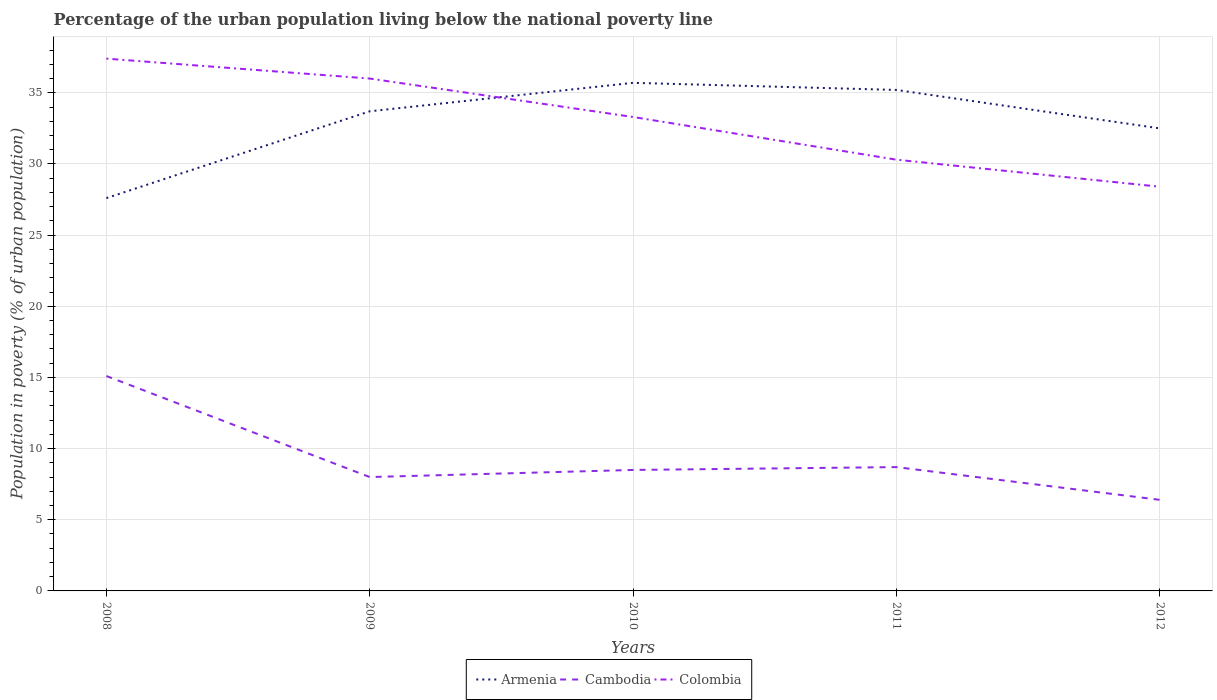How many different coloured lines are there?
Keep it short and to the point. 3. Across all years, what is the maximum percentage of the urban population living below the national poverty line in Cambodia?
Ensure brevity in your answer.  6.4. What is the total percentage of the urban population living below the national poverty line in Cambodia in the graph?
Keep it short and to the point. 6.4. What is the difference between the highest and the lowest percentage of the urban population living below the national poverty line in Armenia?
Offer a terse response. 3. How many lines are there?
Offer a very short reply. 3. What is the difference between two consecutive major ticks on the Y-axis?
Your response must be concise. 5. Are the values on the major ticks of Y-axis written in scientific E-notation?
Ensure brevity in your answer.  No. Does the graph contain any zero values?
Your answer should be very brief. No. How are the legend labels stacked?
Provide a short and direct response. Horizontal. What is the title of the graph?
Keep it short and to the point. Percentage of the urban population living below the national poverty line. Does "Philippines" appear as one of the legend labels in the graph?
Your response must be concise. No. What is the label or title of the X-axis?
Give a very brief answer. Years. What is the label or title of the Y-axis?
Keep it short and to the point. Population in poverty (% of urban population). What is the Population in poverty (% of urban population) of Armenia in 2008?
Provide a short and direct response. 27.6. What is the Population in poverty (% of urban population) of Colombia in 2008?
Your response must be concise. 37.4. What is the Population in poverty (% of urban population) in Armenia in 2009?
Provide a short and direct response. 33.7. What is the Population in poverty (% of urban population) of Colombia in 2009?
Ensure brevity in your answer.  36. What is the Population in poverty (% of urban population) in Armenia in 2010?
Your response must be concise. 35.7. What is the Population in poverty (% of urban population) of Colombia in 2010?
Make the answer very short. 33.3. What is the Population in poverty (% of urban population) in Armenia in 2011?
Your answer should be very brief. 35.2. What is the Population in poverty (% of urban population) in Colombia in 2011?
Keep it short and to the point. 30.3. What is the Population in poverty (% of urban population) in Armenia in 2012?
Provide a short and direct response. 32.5. What is the Population in poverty (% of urban population) in Colombia in 2012?
Offer a terse response. 28.4. Across all years, what is the maximum Population in poverty (% of urban population) in Armenia?
Offer a very short reply. 35.7. Across all years, what is the maximum Population in poverty (% of urban population) of Colombia?
Ensure brevity in your answer.  37.4. Across all years, what is the minimum Population in poverty (% of urban population) of Armenia?
Provide a succinct answer. 27.6. Across all years, what is the minimum Population in poverty (% of urban population) of Colombia?
Offer a terse response. 28.4. What is the total Population in poverty (% of urban population) of Armenia in the graph?
Provide a short and direct response. 164.7. What is the total Population in poverty (% of urban population) of Cambodia in the graph?
Your answer should be compact. 46.7. What is the total Population in poverty (% of urban population) of Colombia in the graph?
Keep it short and to the point. 165.4. What is the difference between the Population in poverty (% of urban population) in Cambodia in 2008 and that in 2009?
Make the answer very short. 7.1. What is the difference between the Population in poverty (% of urban population) of Armenia in 2008 and that in 2010?
Ensure brevity in your answer.  -8.1. What is the difference between the Population in poverty (% of urban population) of Cambodia in 2008 and that in 2010?
Your response must be concise. 6.6. What is the difference between the Population in poverty (% of urban population) in Armenia in 2008 and that in 2011?
Your answer should be very brief. -7.6. What is the difference between the Population in poverty (% of urban population) in Cambodia in 2009 and that in 2010?
Your answer should be very brief. -0.5. What is the difference between the Population in poverty (% of urban population) in Armenia in 2009 and that in 2012?
Offer a very short reply. 1.2. What is the difference between the Population in poverty (% of urban population) in Colombia in 2010 and that in 2011?
Provide a short and direct response. 3. What is the difference between the Population in poverty (% of urban population) of Armenia in 2011 and that in 2012?
Your response must be concise. 2.7. What is the difference between the Population in poverty (% of urban population) of Colombia in 2011 and that in 2012?
Your response must be concise. 1.9. What is the difference between the Population in poverty (% of urban population) of Armenia in 2008 and the Population in poverty (% of urban population) of Cambodia in 2009?
Provide a short and direct response. 19.6. What is the difference between the Population in poverty (% of urban population) in Armenia in 2008 and the Population in poverty (% of urban population) in Colombia in 2009?
Provide a short and direct response. -8.4. What is the difference between the Population in poverty (% of urban population) in Cambodia in 2008 and the Population in poverty (% of urban population) in Colombia in 2009?
Your response must be concise. -20.9. What is the difference between the Population in poverty (% of urban population) in Armenia in 2008 and the Population in poverty (% of urban population) in Colombia in 2010?
Your answer should be compact. -5.7. What is the difference between the Population in poverty (% of urban population) in Cambodia in 2008 and the Population in poverty (% of urban population) in Colombia in 2010?
Your response must be concise. -18.2. What is the difference between the Population in poverty (% of urban population) of Armenia in 2008 and the Population in poverty (% of urban population) of Cambodia in 2011?
Offer a terse response. 18.9. What is the difference between the Population in poverty (% of urban population) of Armenia in 2008 and the Population in poverty (% of urban population) of Colombia in 2011?
Your answer should be compact. -2.7. What is the difference between the Population in poverty (% of urban population) of Cambodia in 2008 and the Population in poverty (% of urban population) of Colombia in 2011?
Keep it short and to the point. -15.2. What is the difference between the Population in poverty (% of urban population) in Armenia in 2008 and the Population in poverty (% of urban population) in Cambodia in 2012?
Offer a very short reply. 21.2. What is the difference between the Population in poverty (% of urban population) in Armenia in 2009 and the Population in poverty (% of urban population) in Cambodia in 2010?
Offer a very short reply. 25.2. What is the difference between the Population in poverty (% of urban population) of Armenia in 2009 and the Population in poverty (% of urban population) of Colombia in 2010?
Keep it short and to the point. 0.4. What is the difference between the Population in poverty (% of urban population) of Cambodia in 2009 and the Population in poverty (% of urban population) of Colombia in 2010?
Make the answer very short. -25.3. What is the difference between the Population in poverty (% of urban population) of Armenia in 2009 and the Population in poverty (% of urban population) of Cambodia in 2011?
Your response must be concise. 25. What is the difference between the Population in poverty (% of urban population) of Armenia in 2009 and the Population in poverty (% of urban population) of Colombia in 2011?
Keep it short and to the point. 3.4. What is the difference between the Population in poverty (% of urban population) of Cambodia in 2009 and the Population in poverty (% of urban population) of Colombia in 2011?
Your response must be concise. -22.3. What is the difference between the Population in poverty (% of urban population) in Armenia in 2009 and the Population in poverty (% of urban population) in Cambodia in 2012?
Make the answer very short. 27.3. What is the difference between the Population in poverty (% of urban population) of Armenia in 2009 and the Population in poverty (% of urban population) of Colombia in 2012?
Ensure brevity in your answer.  5.3. What is the difference between the Population in poverty (% of urban population) in Cambodia in 2009 and the Population in poverty (% of urban population) in Colombia in 2012?
Your answer should be very brief. -20.4. What is the difference between the Population in poverty (% of urban population) in Armenia in 2010 and the Population in poverty (% of urban population) in Cambodia in 2011?
Offer a terse response. 27. What is the difference between the Population in poverty (% of urban population) in Armenia in 2010 and the Population in poverty (% of urban population) in Colombia in 2011?
Offer a terse response. 5.4. What is the difference between the Population in poverty (% of urban population) in Cambodia in 2010 and the Population in poverty (% of urban population) in Colombia in 2011?
Provide a succinct answer. -21.8. What is the difference between the Population in poverty (% of urban population) of Armenia in 2010 and the Population in poverty (% of urban population) of Cambodia in 2012?
Provide a short and direct response. 29.3. What is the difference between the Population in poverty (% of urban population) in Cambodia in 2010 and the Population in poverty (% of urban population) in Colombia in 2012?
Offer a terse response. -19.9. What is the difference between the Population in poverty (% of urban population) in Armenia in 2011 and the Population in poverty (% of urban population) in Cambodia in 2012?
Give a very brief answer. 28.8. What is the difference between the Population in poverty (% of urban population) in Cambodia in 2011 and the Population in poverty (% of urban population) in Colombia in 2012?
Provide a short and direct response. -19.7. What is the average Population in poverty (% of urban population) of Armenia per year?
Provide a succinct answer. 32.94. What is the average Population in poverty (% of urban population) of Cambodia per year?
Your response must be concise. 9.34. What is the average Population in poverty (% of urban population) of Colombia per year?
Your answer should be very brief. 33.08. In the year 2008, what is the difference between the Population in poverty (% of urban population) of Cambodia and Population in poverty (% of urban population) of Colombia?
Give a very brief answer. -22.3. In the year 2009, what is the difference between the Population in poverty (% of urban population) in Armenia and Population in poverty (% of urban population) in Cambodia?
Offer a terse response. 25.7. In the year 2009, what is the difference between the Population in poverty (% of urban population) in Armenia and Population in poverty (% of urban population) in Colombia?
Make the answer very short. -2.3. In the year 2010, what is the difference between the Population in poverty (% of urban population) of Armenia and Population in poverty (% of urban population) of Cambodia?
Make the answer very short. 27.2. In the year 2010, what is the difference between the Population in poverty (% of urban population) in Cambodia and Population in poverty (% of urban population) in Colombia?
Ensure brevity in your answer.  -24.8. In the year 2011, what is the difference between the Population in poverty (% of urban population) in Armenia and Population in poverty (% of urban population) in Colombia?
Your answer should be compact. 4.9. In the year 2011, what is the difference between the Population in poverty (% of urban population) of Cambodia and Population in poverty (% of urban population) of Colombia?
Offer a terse response. -21.6. In the year 2012, what is the difference between the Population in poverty (% of urban population) in Armenia and Population in poverty (% of urban population) in Cambodia?
Your answer should be compact. 26.1. In the year 2012, what is the difference between the Population in poverty (% of urban population) in Cambodia and Population in poverty (% of urban population) in Colombia?
Offer a very short reply. -22. What is the ratio of the Population in poverty (% of urban population) in Armenia in 2008 to that in 2009?
Make the answer very short. 0.82. What is the ratio of the Population in poverty (% of urban population) in Cambodia in 2008 to that in 2009?
Give a very brief answer. 1.89. What is the ratio of the Population in poverty (% of urban population) of Colombia in 2008 to that in 2009?
Your answer should be very brief. 1.04. What is the ratio of the Population in poverty (% of urban population) in Armenia in 2008 to that in 2010?
Your response must be concise. 0.77. What is the ratio of the Population in poverty (% of urban population) of Cambodia in 2008 to that in 2010?
Make the answer very short. 1.78. What is the ratio of the Population in poverty (% of urban population) of Colombia in 2008 to that in 2010?
Provide a short and direct response. 1.12. What is the ratio of the Population in poverty (% of urban population) of Armenia in 2008 to that in 2011?
Provide a short and direct response. 0.78. What is the ratio of the Population in poverty (% of urban population) in Cambodia in 2008 to that in 2011?
Offer a very short reply. 1.74. What is the ratio of the Population in poverty (% of urban population) in Colombia in 2008 to that in 2011?
Your answer should be compact. 1.23. What is the ratio of the Population in poverty (% of urban population) in Armenia in 2008 to that in 2012?
Give a very brief answer. 0.85. What is the ratio of the Population in poverty (% of urban population) of Cambodia in 2008 to that in 2012?
Ensure brevity in your answer.  2.36. What is the ratio of the Population in poverty (% of urban population) in Colombia in 2008 to that in 2012?
Offer a terse response. 1.32. What is the ratio of the Population in poverty (% of urban population) in Armenia in 2009 to that in 2010?
Your response must be concise. 0.94. What is the ratio of the Population in poverty (% of urban population) of Colombia in 2009 to that in 2010?
Make the answer very short. 1.08. What is the ratio of the Population in poverty (% of urban population) of Armenia in 2009 to that in 2011?
Ensure brevity in your answer.  0.96. What is the ratio of the Population in poverty (% of urban population) of Cambodia in 2009 to that in 2011?
Keep it short and to the point. 0.92. What is the ratio of the Population in poverty (% of urban population) of Colombia in 2009 to that in 2011?
Offer a very short reply. 1.19. What is the ratio of the Population in poverty (% of urban population) of Armenia in 2009 to that in 2012?
Your answer should be compact. 1.04. What is the ratio of the Population in poverty (% of urban population) in Cambodia in 2009 to that in 2012?
Make the answer very short. 1.25. What is the ratio of the Population in poverty (% of urban population) in Colombia in 2009 to that in 2012?
Your response must be concise. 1.27. What is the ratio of the Population in poverty (% of urban population) of Armenia in 2010 to that in 2011?
Offer a very short reply. 1.01. What is the ratio of the Population in poverty (% of urban population) in Cambodia in 2010 to that in 2011?
Your answer should be compact. 0.98. What is the ratio of the Population in poverty (% of urban population) in Colombia in 2010 to that in 2011?
Offer a terse response. 1.1. What is the ratio of the Population in poverty (% of urban population) in Armenia in 2010 to that in 2012?
Your answer should be very brief. 1.1. What is the ratio of the Population in poverty (% of urban population) of Cambodia in 2010 to that in 2012?
Keep it short and to the point. 1.33. What is the ratio of the Population in poverty (% of urban population) of Colombia in 2010 to that in 2012?
Make the answer very short. 1.17. What is the ratio of the Population in poverty (% of urban population) of Armenia in 2011 to that in 2012?
Make the answer very short. 1.08. What is the ratio of the Population in poverty (% of urban population) of Cambodia in 2011 to that in 2012?
Offer a very short reply. 1.36. What is the ratio of the Population in poverty (% of urban population) of Colombia in 2011 to that in 2012?
Provide a succinct answer. 1.07. What is the difference between the highest and the second highest Population in poverty (% of urban population) of Cambodia?
Make the answer very short. 6.4. What is the difference between the highest and the lowest Population in poverty (% of urban population) of Armenia?
Offer a terse response. 8.1. What is the difference between the highest and the lowest Population in poverty (% of urban population) in Cambodia?
Offer a very short reply. 8.7. 